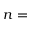<formula> <loc_0><loc_0><loc_500><loc_500>n =</formula> 